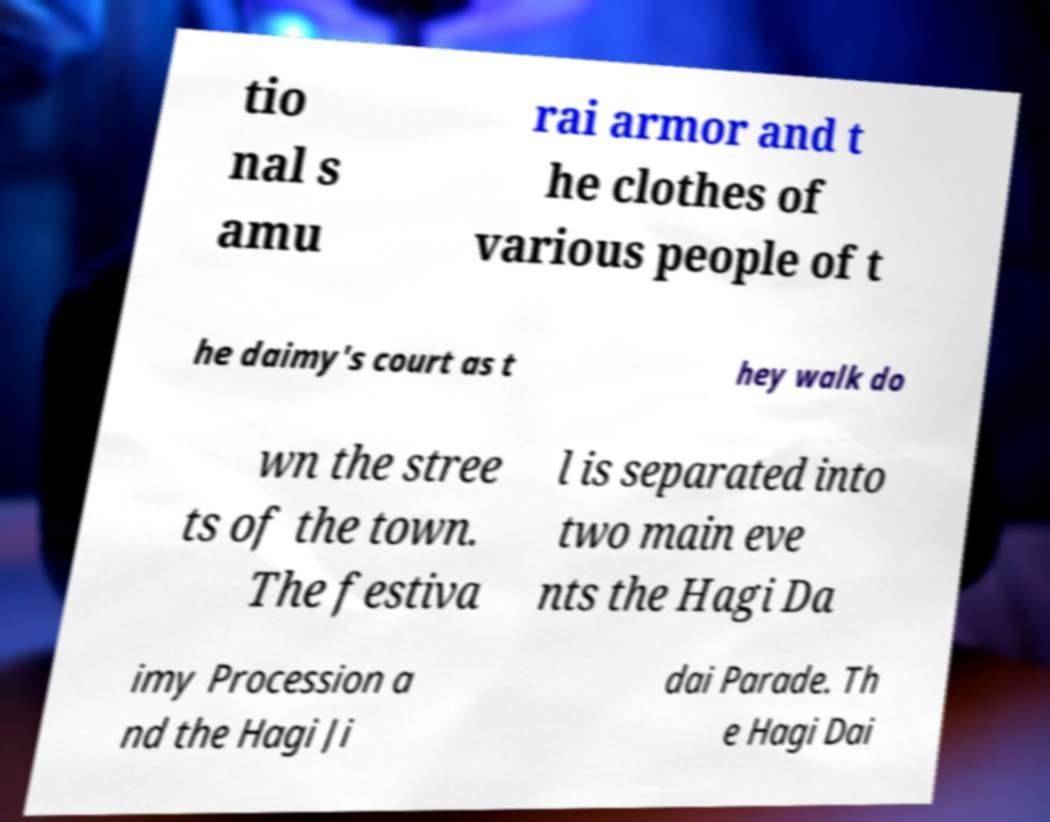Could you assist in decoding the text presented in this image and type it out clearly? tio nal s amu rai armor and t he clothes of various people of t he daimy's court as t hey walk do wn the stree ts of the town. The festiva l is separated into two main eve nts the Hagi Da imy Procession a nd the Hagi Ji dai Parade. Th e Hagi Dai 